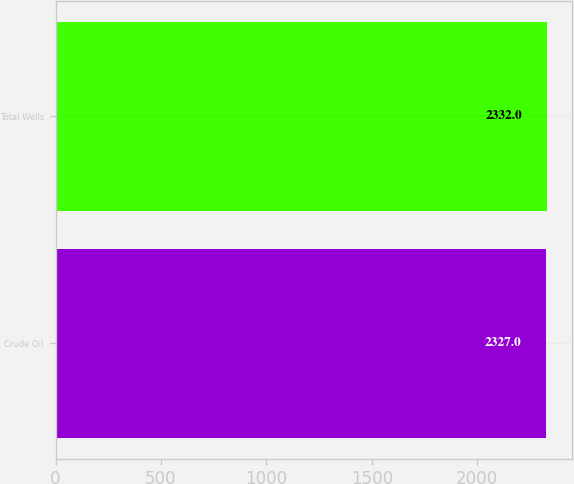Convert chart. <chart><loc_0><loc_0><loc_500><loc_500><bar_chart><fcel>Crude Oil<fcel>Total Wells<nl><fcel>2327<fcel>2332<nl></chart> 